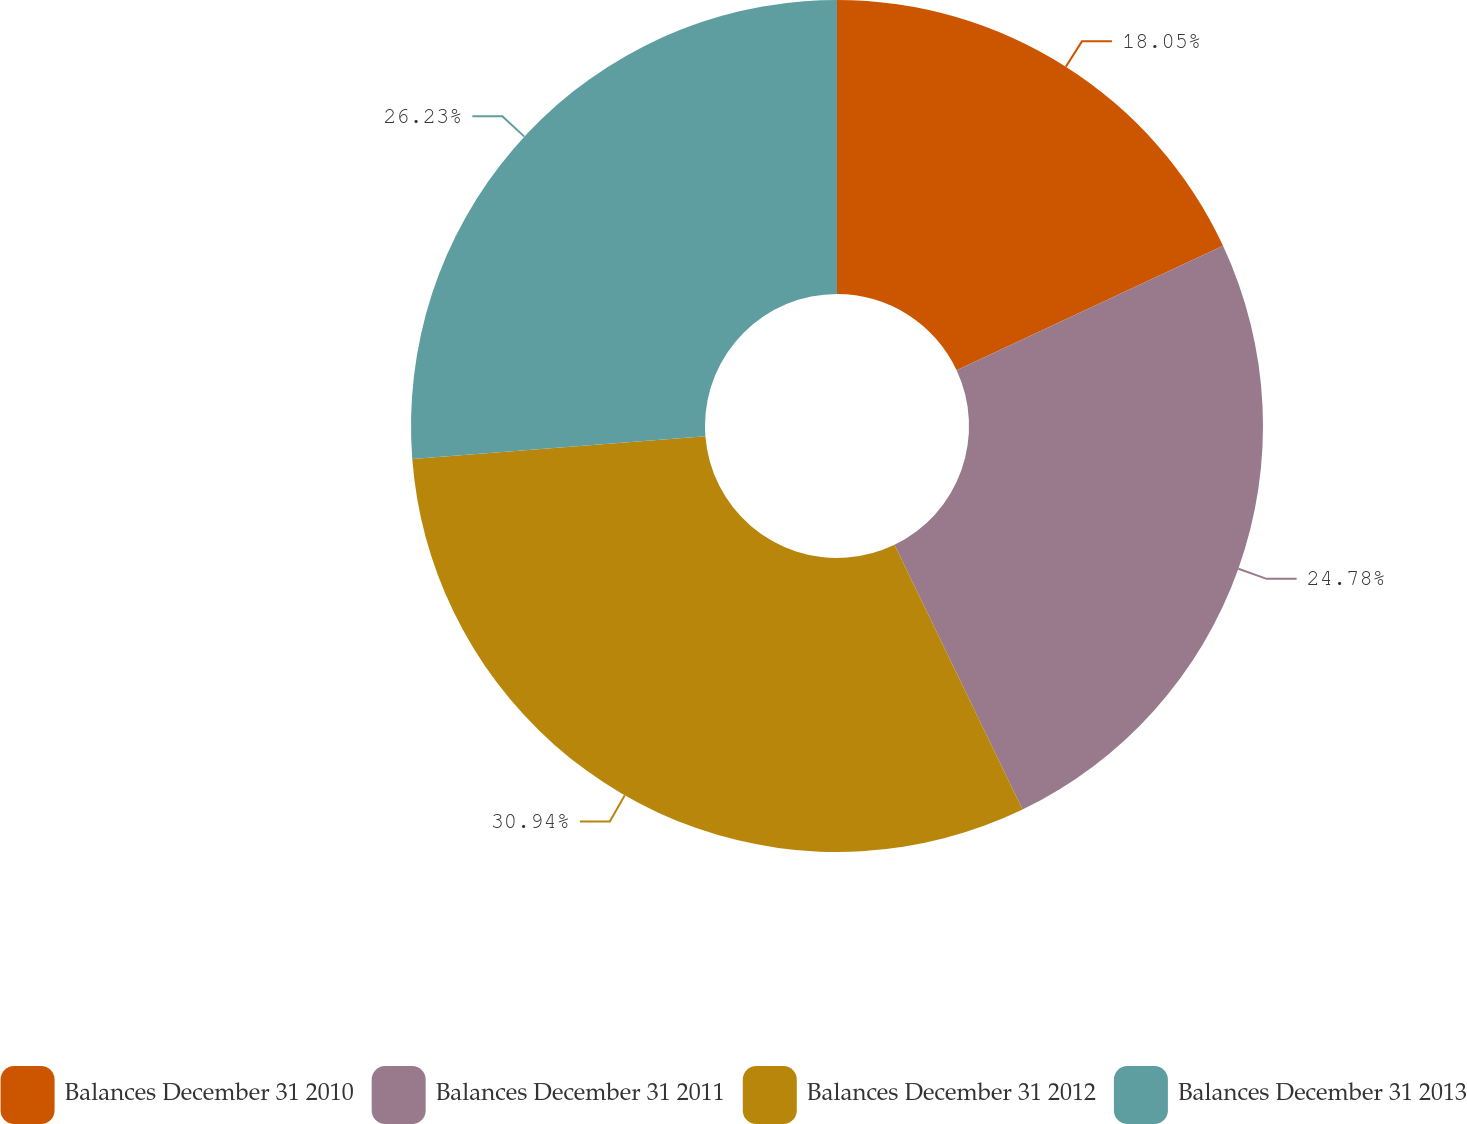<chart> <loc_0><loc_0><loc_500><loc_500><pie_chart><fcel>Balances December 31 2010<fcel>Balances December 31 2011<fcel>Balances December 31 2012<fcel>Balances December 31 2013<nl><fcel>18.05%<fcel>24.78%<fcel>30.94%<fcel>26.23%<nl></chart> 